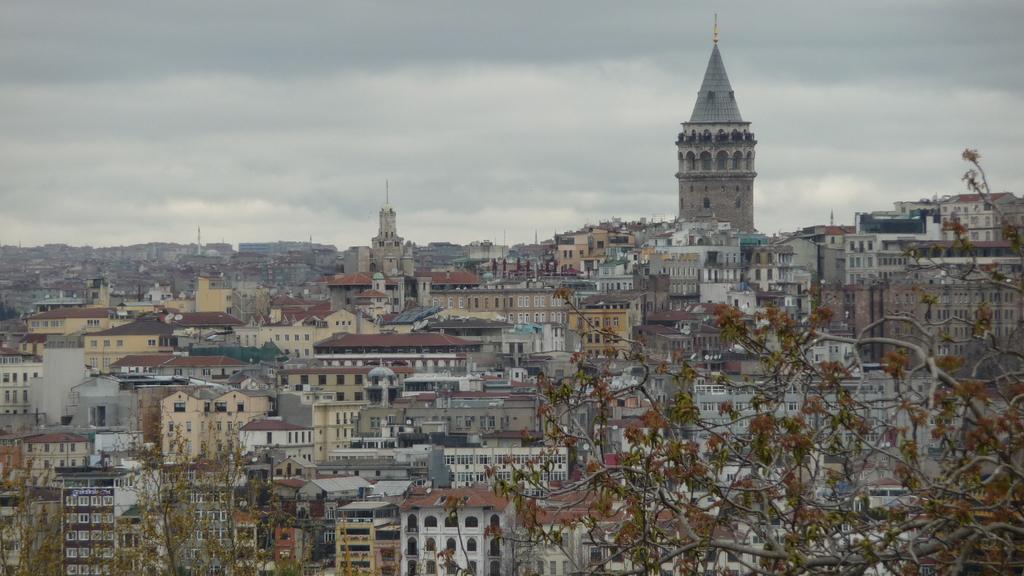In one or two sentences, can you explain what this image depicts? In the foreground of the image we can see trees and buildings. In the middle of the image we can see buildings. On the top of the image we can see the sky. 